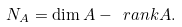<formula> <loc_0><loc_0><loc_500><loc_500>N _ { A } = \dim A - \ r a n k A .</formula> 